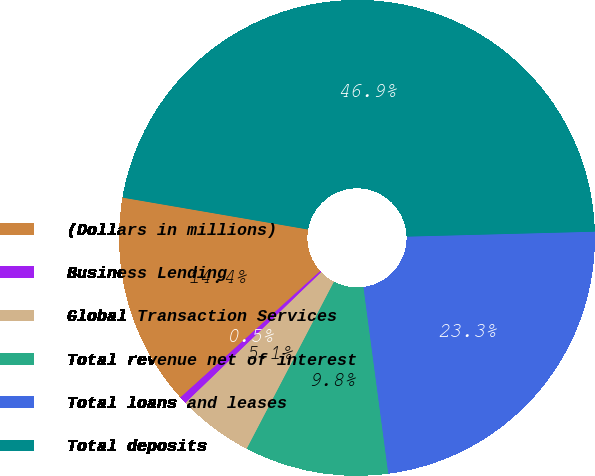<chart> <loc_0><loc_0><loc_500><loc_500><pie_chart><fcel>(Dollars in millions)<fcel>Business Lending<fcel>Global Transaction Services<fcel>Total revenue net of interest<fcel>Total loans and leases<fcel>Total deposits<nl><fcel>14.41%<fcel>0.5%<fcel>5.14%<fcel>9.77%<fcel>23.31%<fcel>46.87%<nl></chart> 